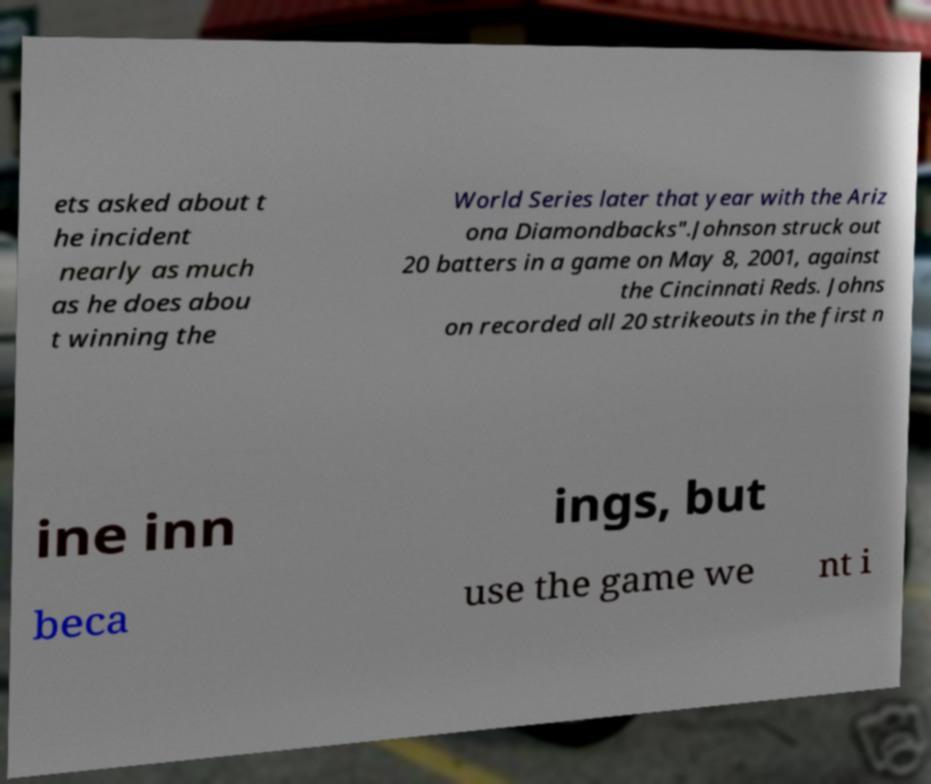For documentation purposes, I need the text within this image transcribed. Could you provide that? ets asked about t he incident nearly as much as he does abou t winning the World Series later that year with the Ariz ona Diamondbacks".Johnson struck out 20 batters in a game on May 8, 2001, against the Cincinnati Reds. Johns on recorded all 20 strikeouts in the first n ine inn ings, but beca use the game we nt i 